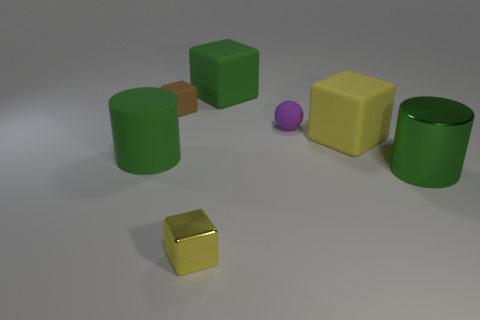Subtract all brown balls. How many yellow cubes are left? 2 Subtract all brown cubes. How many cubes are left? 3 Subtract 1 blocks. How many blocks are left? 3 Subtract all rubber blocks. How many blocks are left? 1 Subtract all cyan cubes. Subtract all purple cylinders. How many cubes are left? 4 Add 2 red matte balls. How many objects exist? 9 Subtract all cubes. How many objects are left? 3 Subtract 0 gray blocks. How many objects are left? 7 Subtract all small gray matte blocks. Subtract all matte cylinders. How many objects are left? 6 Add 7 large cylinders. How many large cylinders are left? 9 